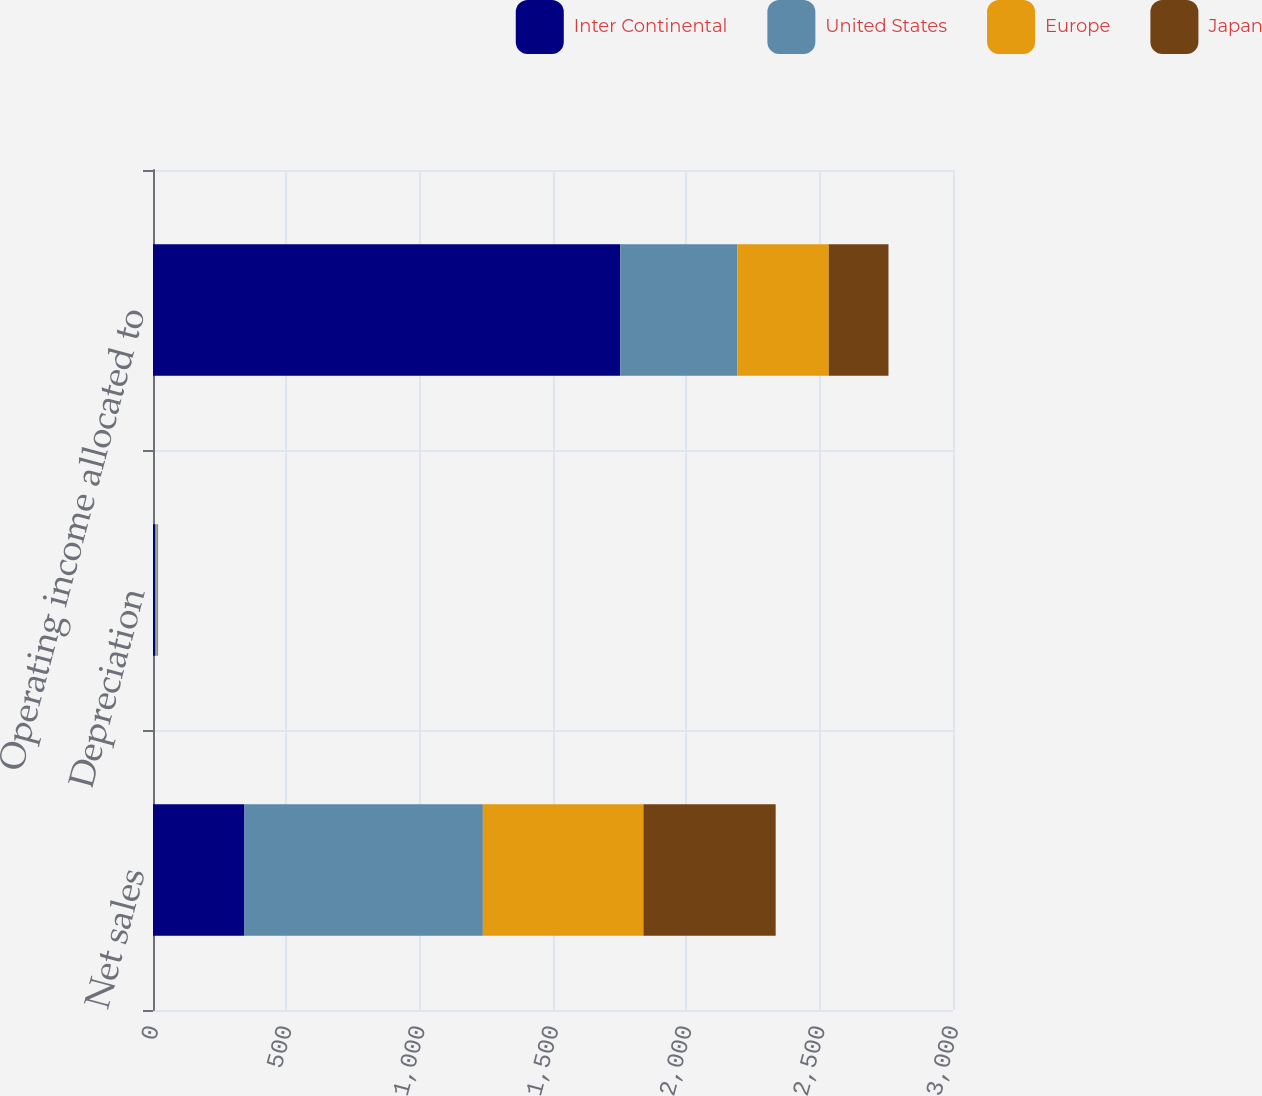<chart> <loc_0><loc_0><loc_500><loc_500><stacked_bar_chart><ecel><fcel>Net sales<fcel>Depreciation<fcel>Operating income allocated to<nl><fcel>Inter Continental<fcel>343<fcel>9<fcel>1752<nl><fcel>United States<fcel>894<fcel>5<fcel>439<nl><fcel>Europe<fcel>602<fcel>3<fcel>343<nl><fcel>Japan<fcel>496<fcel>2<fcel>224<nl></chart> 